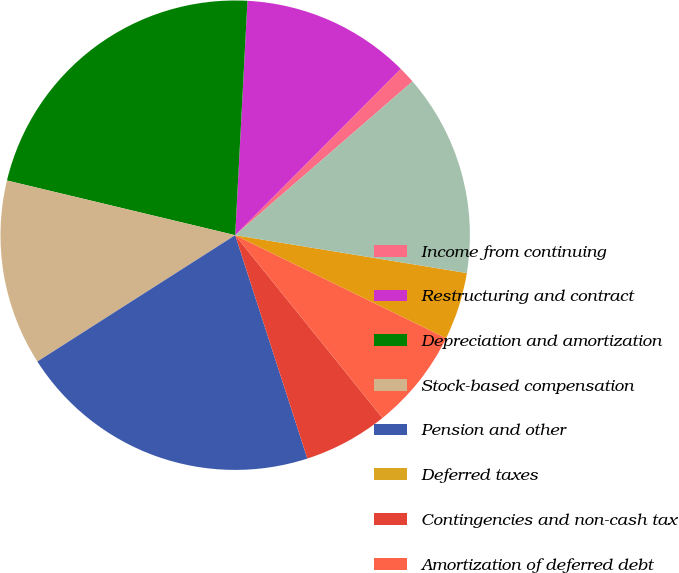<chart> <loc_0><loc_0><loc_500><loc_500><pie_chart><fcel>Income from continuing<fcel>Restructuring and contract<fcel>Depreciation and amortization<fcel>Stock-based compensation<fcel>Pension and other<fcel>Deferred taxes<fcel>Contingencies and non-cash tax<fcel>Amortization of deferred debt<fcel>Asset Impairments<fcel>Accounts receivable net<nl><fcel>1.17%<fcel>11.63%<fcel>22.09%<fcel>12.79%<fcel>20.93%<fcel>0.0%<fcel>5.82%<fcel>6.98%<fcel>4.65%<fcel>13.95%<nl></chart> 